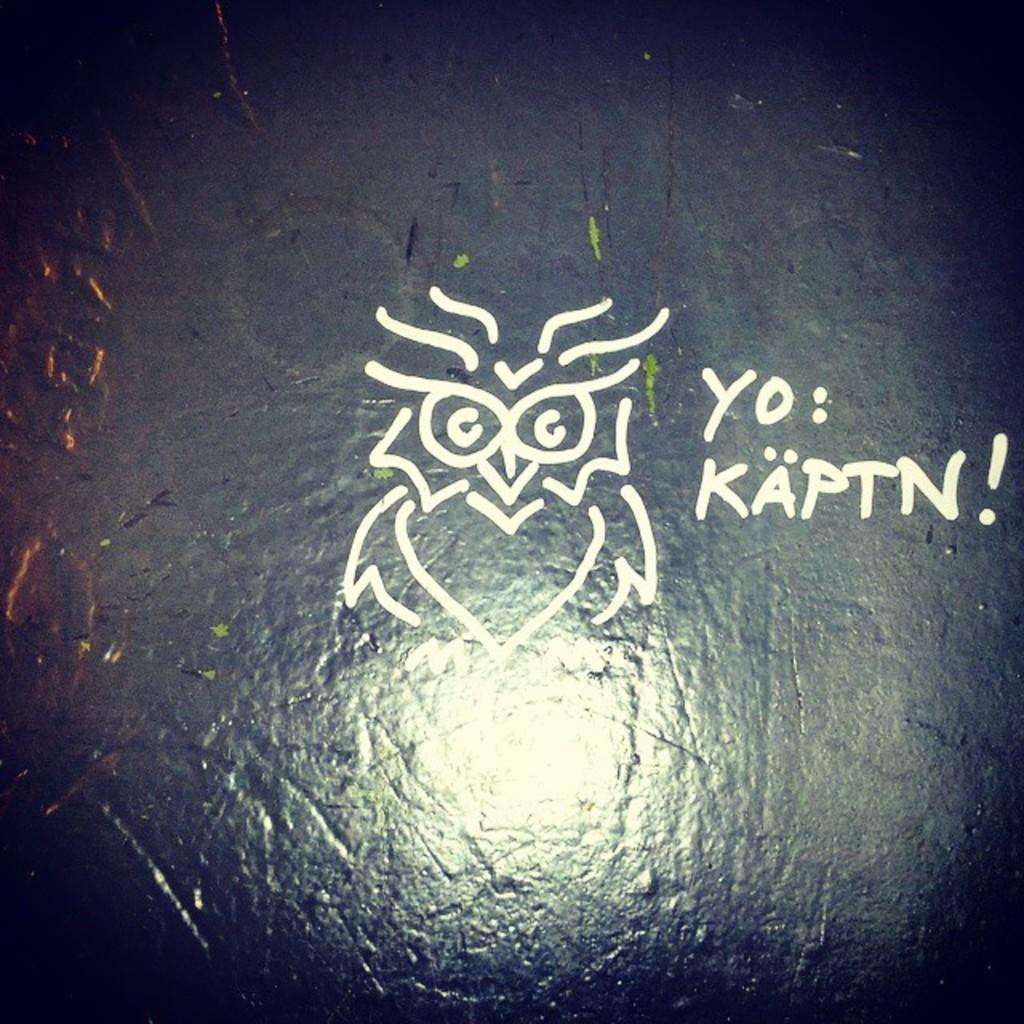Can you describe this image briefly? In this image we can see the text and a design on the stone surface. 